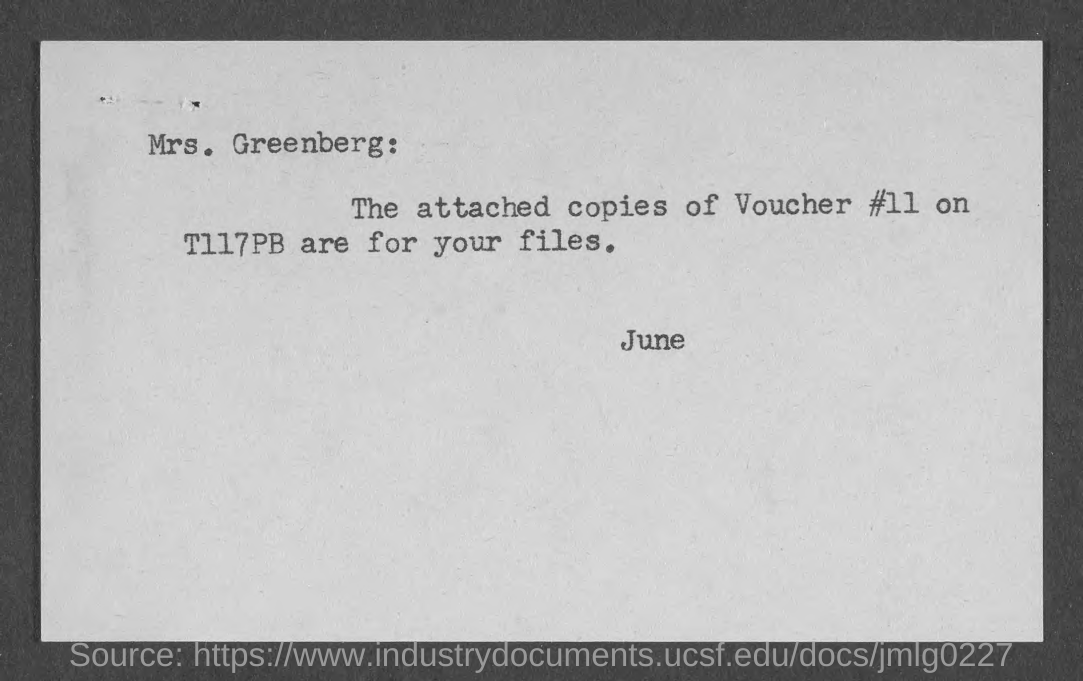Who is the addressee of this document?
Your answer should be very brief. Mrs. Greenberg. What is the voucher# given in the document?
Your answer should be compact. Voucher #11. Who is the sender of this document?
Provide a short and direct response. June. 